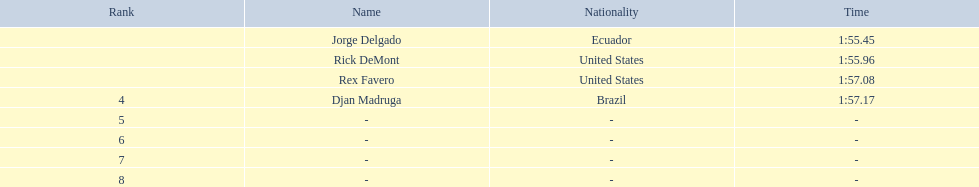Who finished with the top time? Jorge Delgado. Write the full table. {'header': ['Rank', 'Name', 'Nationality', 'Time'], 'rows': [['', 'Jorge Delgado', 'Ecuador', '1:55.45'], ['', 'Rick DeMont', 'United States', '1:55.96'], ['', 'Rex Favero', 'United States', '1:57.08'], ['4', 'Djan Madruga', 'Brazil', '1:57.17'], ['5', '-', '-', '-'], ['6', '-', '-', '-'], ['7', '-', '-', '-'], ['8', '-', '-', '-']]} 